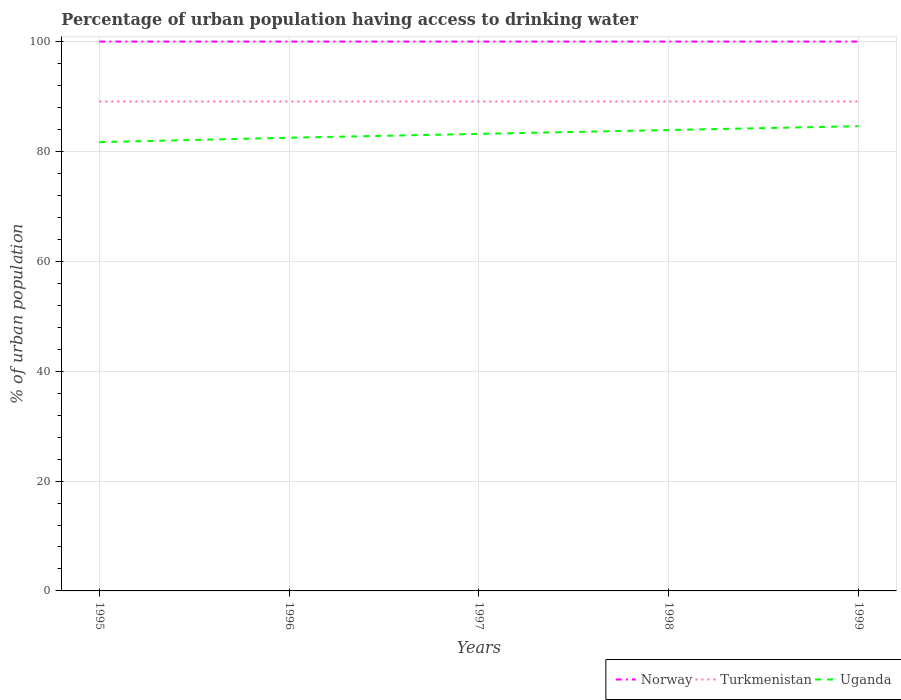How many different coloured lines are there?
Give a very brief answer. 3. Is the number of lines equal to the number of legend labels?
Your answer should be very brief. Yes. Across all years, what is the maximum percentage of urban population having access to drinking water in Uganda?
Your answer should be compact. 81.7. In which year was the percentage of urban population having access to drinking water in Norway maximum?
Provide a succinct answer. 1995. What is the total percentage of urban population having access to drinking water in Norway in the graph?
Offer a terse response. 0. What is the difference between the highest and the second highest percentage of urban population having access to drinking water in Uganda?
Your answer should be very brief. 2.9. How many years are there in the graph?
Your response must be concise. 5. Does the graph contain grids?
Make the answer very short. Yes. How many legend labels are there?
Ensure brevity in your answer.  3. What is the title of the graph?
Your response must be concise. Percentage of urban population having access to drinking water. What is the label or title of the Y-axis?
Your answer should be very brief. % of urban population. What is the % of urban population in Turkmenistan in 1995?
Make the answer very short. 89.1. What is the % of urban population of Uganda in 1995?
Provide a succinct answer. 81.7. What is the % of urban population of Norway in 1996?
Your response must be concise. 100. What is the % of urban population in Turkmenistan in 1996?
Make the answer very short. 89.1. What is the % of urban population in Uganda in 1996?
Keep it short and to the point. 82.5. What is the % of urban population of Turkmenistan in 1997?
Your answer should be very brief. 89.1. What is the % of urban population in Uganda in 1997?
Provide a succinct answer. 83.2. What is the % of urban population in Norway in 1998?
Your response must be concise. 100. What is the % of urban population of Turkmenistan in 1998?
Make the answer very short. 89.1. What is the % of urban population of Uganda in 1998?
Make the answer very short. 83.9. What is the % of urban population of Norway in 1999?
Provide a short and direct response. 100. What is the % of urban population of Turkmenistan in 1999?
Keep it short and to the point. 89.1. What is the % of urban population of Uganda in 1999?
Give a very brief answer. 84.6. Across all years, what is the maximum % of urban population in Norway?
Give a very brief answer. 100. Across all years, what is the maximum % of urban population of Turkmenistan?
Your answer should be compact. 89.1. Across all years, what is the maximum % of urban population in Uganda?
Provide a short and direct response. 84.6. Across all years, what is the minimum % of urban population in Turkmenistan?
Offer a terse response. 89.1. Across all years, what is the minimum % of urban population in Uganda?
Offer a very short reply. 81.7. What is the total % of urban population in Norway in the graph?
Give a very brief answer. 500. What is the total % of urban population of Turkmenistan in the graph?
Your answer should be very brief. 445.5. What is the total % of urban population in Uganda in the graph?
Your answer should be very brief. 415.9. What is the difference between the % of urban population in Turkmenistan in 1995 and that in 1996?
Ensure brevity in your answer.  0. What is the difference between the % of urban population of Norway in 1995 and that in 1997?
Your response must be concise. 0. What is the difference between the % of urban population of Uganda in 1995 and that in 1997?
Provide a succinct answer. -1.5. What is the difference between the % of urban population in Norway in 1995 and that in 1998?
Your answer should be compact. 0. What is the difference between the % of urban population of Norway in 1995 and that in 1999?
Make the answer very short. 0. What is the difference between the % of urban population of Turkmenistan in 1996 and that in 1997?
Make the answer very short. 0. What is the difference between the % of urban population of Uganda in 1996 and that in 1997?
Offer a terse response. -0.7. What is the difference between the % of urban population in Norway in 1996 and that in 1999?
Your answer should be very brief. 0. What is the difference between the % of urban population in Turkmenistan in 1996 and that in 1999?
Your response must be concise. 0. What is the difference between the % of urban population of Norway in 1997 and that in 1999?
Give a very brief answer. 0. What is the difference between the % of urban population of Uganda in 1997 and that in 1999?
Provide a succinct answer. -1.4. What is the difference between the % of urban population of Turkmenistan in 1998 and that in 1999?
Your answer should be compact. 0. What is the difference between the % of urban population of Norway in 1995 and the % of urban population of Uganda in 1996?
Give a very brief answer. 17.5. What is the difference between the % of urban population in Norway in 1995 and the % of urban population in Turkmenistan in 1997?
Offer a terse response. 10.9. What is the difference between the % of urban population in Turkmenistan in 1995 and the % of urban population in Uganda in 1997?
Your answer should be very brief. 5.9. What is the difference between the % of urban population of Norway in 1995 and the % of urban population of Turkmenistan in 1999?
Your response must be concise. 10.9. What is the difference between the % of urban population of Turkmenistan in 1995 and the % of urban population of Uganda in 1999?
Your answer should be very brief. 4.5. What is the difference between the % of urban population in Norway in 1996 and the % of urban population in Uganda in 1997?
Provide a short and direct response. 16.8. What is the difference between the % of urban population of Norway in 1996 and the % of urban population of Turkmenistan in 1998?
Offer a very short reply. 10.9. What is the difference between the % of urban population of Turkmenistan in 1996 and the % of urban population of Uganda in 1998?
Your answer should be very brief. 5.2. What is the difference between the % of urban population of Norway in 1996 and the % of urban population of Turkmenistan in 1999?
Your response must be concise. 10.9. What is the difference between the % of urban population in Norway in 1996 and the % of urban population in Uganda in 1999?
Your answer should be very brief. 15.4. What is the difference between the % of urban population in Norway in 1997 and the % of urban population in Turkmenistan in 1998?
Make the answer very short. 10.9. What is the difference between the % of urban population in Norway in 1997 and the % of urban population in Uganda in 1998?
Ensure brevity in your answer.  16.1. What is the difference between the % of urban population in Turkmenistan in 1997 and the % of urban population in Uganda in 1998?
Your answer should be compact. 5.2. What is the difference between the % of urban population in Turkmenistan in 1997 and the % of urban population in Uganda in 1999?
Your response must be concise. 4.5. What is the difference between the % of urban population in Turkmenistan in 1998 and the % of urban population in Uganda in 1999?
Provide a succinct answer. 4.5. What is the average % of urban population of Norway per year?
Ensure brevity in your answer.  100. What is the average % of urban population in Turkmenistan per year?
Provide a short and direct response. 89.1. What is the average % of urban population of Uganda per year?
Give a very brief answer. 83.18. In the year 1995, what is the difference between the % of urban population of Turkmenistan and % of urban population of Uganda?
Provide a succinct answer. 7.4. In the year 1996, what is the difference between the % of urban population of Norway and % of urban population of Turkmenistan?
Give a very brief answer. 10.9. In the year 1996, what is the difference between the % of urban population in Norway and % of urban population in Uganda?
Offer a very short reply. 17.5. In the year 1997, what is the difference between the % of urban population in Norway and % of urban population in Turkmenistan?
Give a very brief answer. 10.9. In the year 1997, what is the difference between the % of urban population of Turkmenistan and % of urban population of Uganda?
Offer a very short reply. 5.9. In the year 1998, what is the difference between the % of urban population in Norway and % of urban population in Turkmenistan?
Make the answer very short. 10.9. In the year 1998, what is the difference between the % of urban population of Norway and % of urban population of Uganda?
Your answer should be very brief. 16.1. In the year 1998, what is the difference between the % of urban population of Turkmenistan and % of urban population of Uganda?
Provide a short and direct response. 5.2. In the year 1999, what is the difference between the % of urban population in Norway and % of urban population in Turkmenistan?
Your answer should be very brief. 10.9. What is the ratio of the % of urban population in Norway in 1995 to that in 1996?
Your answer should be compact. 1. What is the ratio of the % of urban population of Uganda in 1995 to that in 1996?
Your answer should be compact. 0.99. What is the ratio of the % of urban population in Uganda in 1995 to that in 1997?
Offer a very short reply. 0.98. What is the ratio of the % of urban population in Norway in 1995 to that in 1998?
Keep it short and to the point. 1. What is the ratio of the % of urban population of Uganda in 1995 to that in 1998?
Make the answer very short. 0.97. What is the ratio of the % of urban population in Norway in 1995 to that in 1999?
Provide a succinct answer. 1. What is the ratio of the % of urban population of Uganda in 1995 to that in 1999?
Your response must be concise. 0.97. What is the ratio of the % of urban population of Norway in 1996 to that in 1997?
Provide a short and direct response. 1. What is the ratio of the % of urban population of Turkmenistan in 1996 to that in 1998?
Your answer should be very brief. 1. What is the ratio of the % of urban population of Uganda in 1996 to that in 1998?
Provide a short and direct response. 0.98. What is the ratio of the % of urban population in Norway in 1996 to that in 1999?
Keep it short and to the point. 1. What is the ratio of the % of urban population in Uganda in 1996 to that in 1999?
Ensure brevity in your answer.  0.98. What is the ratio of the % of urban population in Norway in 1997 to that in 1998?
Your response must be concise. 1. What is the ratio of the % of urban population in Turkmenistan in 1997 to that in 1998?
Provide a short and direct response. 1. What is the ratio of the % of urban population of Norway in 1997 to that in 1999?
Make the answer very short. 1. What is the ratio of the % of urban population in Uganda in 1997 to that in 1999?
Make the answer very short. 0.98. What is the ratio of the % of urban population of Norway in 1998 to that in 1999?
Your answer should be very brief. 1. What is the ratio of the % of urban population in Turkmenistan in 1998 to that in 1999?
Provide a short and direct response. 1. What is the difference between the highest and the lowest % of urban population of Norway?
Your answer should be very brief. 0. 